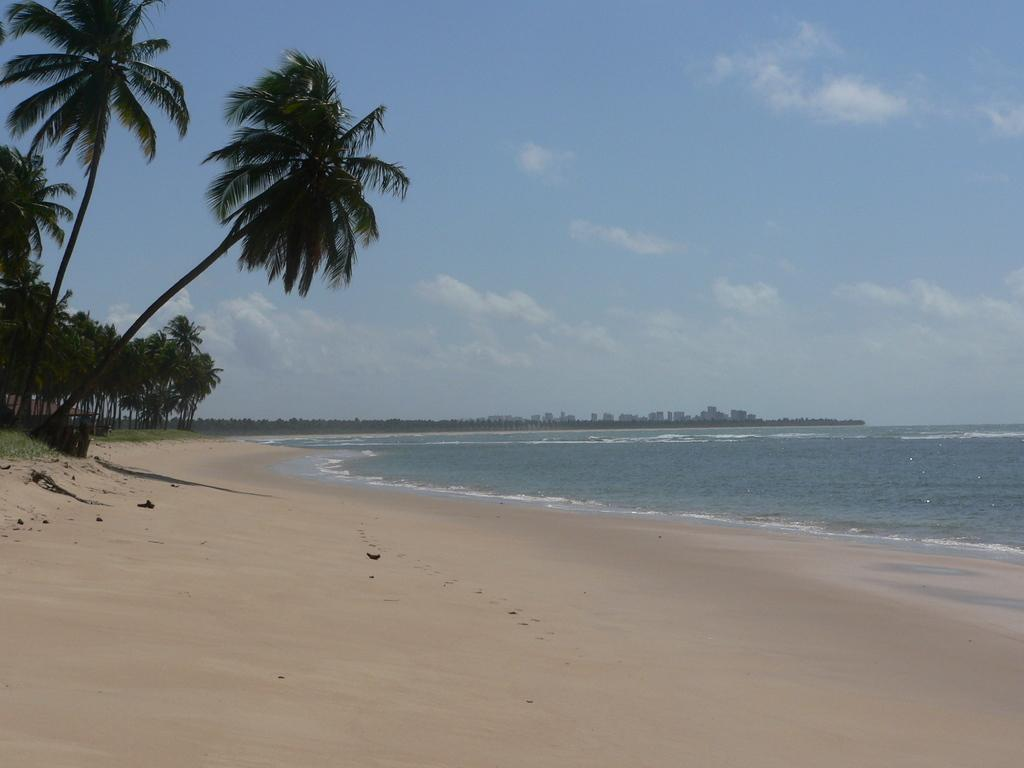What is the primary element in the image? There is water in the image. What type of vegetation is present in the image? There are trees in the image, and they are green. What can be seen in the background of the image? There are buildings in the background of the image. What is the color of the sky in the image? The sky is visible in the image, and it is blue and white. What type of cake is being served on the water in the image? There is no cake present in the image; it features water, green trees, buildings in the background, and a blue and white sky. 